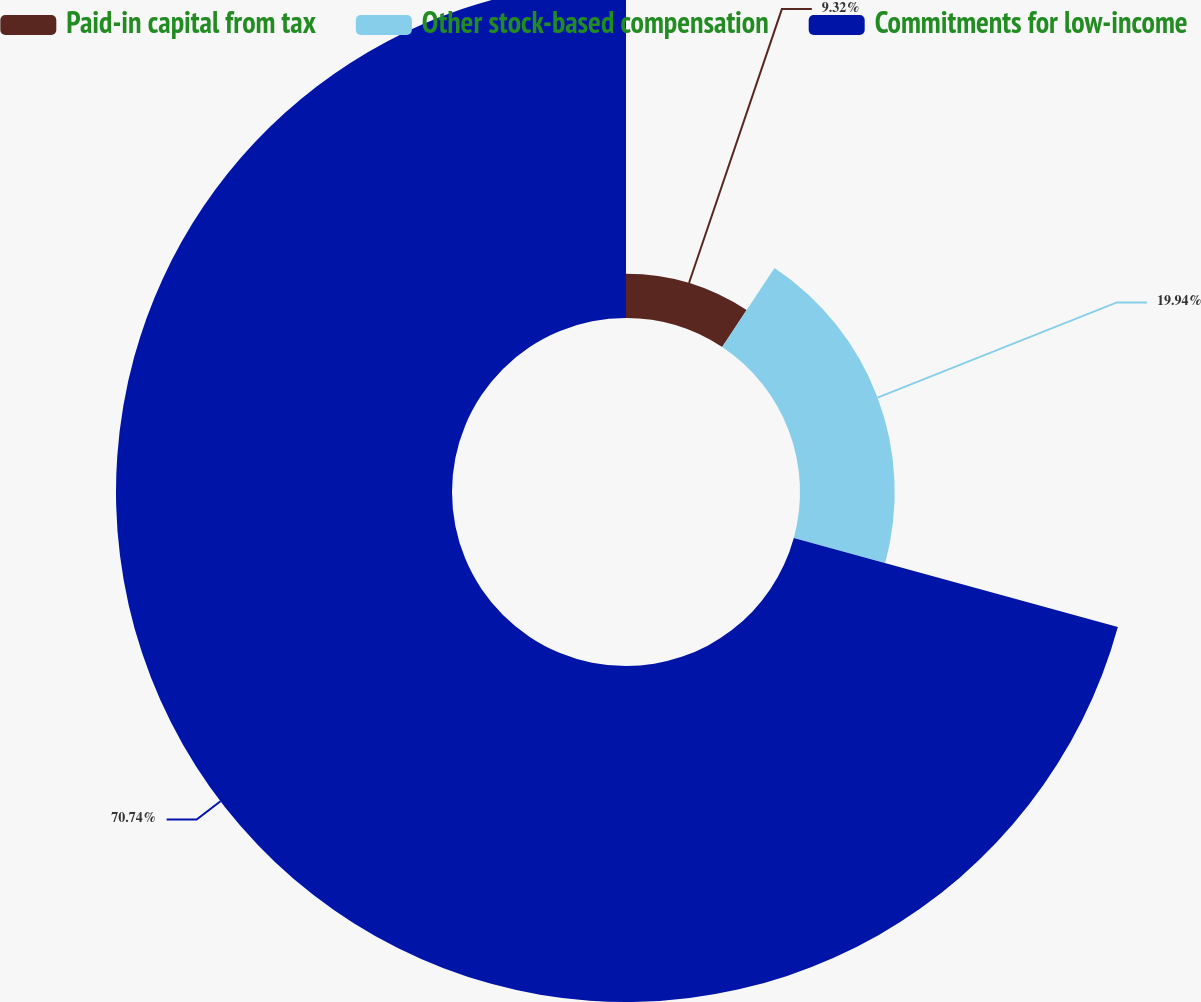Convert chart. <chart><loc_0><loc_0><loc_500><loc_500><pie_chart><fcel>Paid-in capital from tax<fcel>Other stock-based compensation<fcel>Commitments for low-income<nl><fcel>9.32%<fcel>19.94%<fcel>70.74%<nl></chart> 